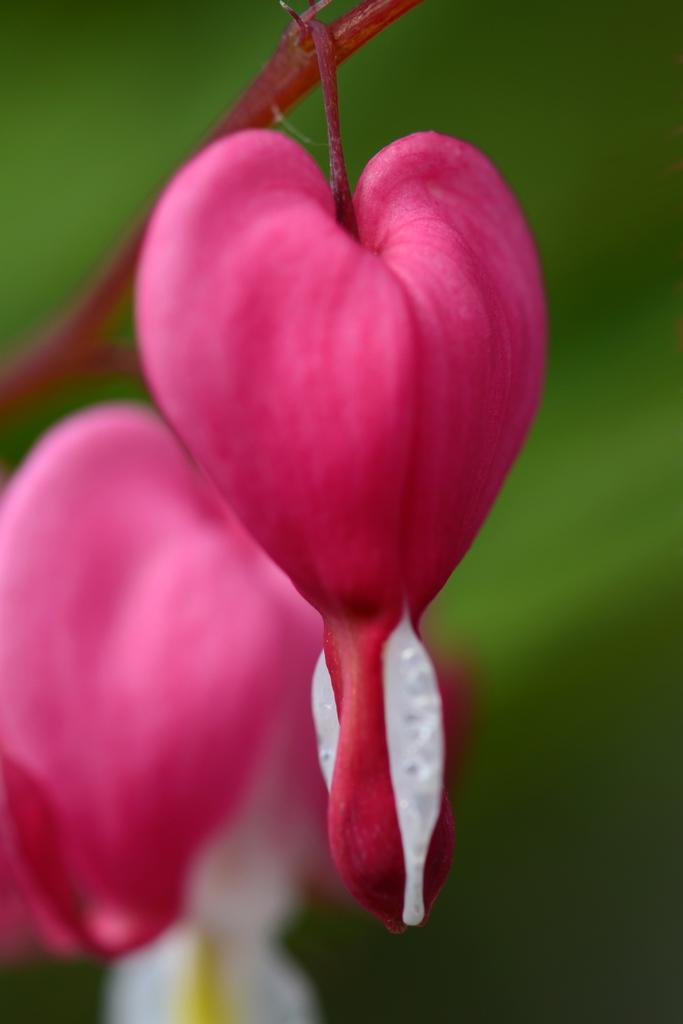What type of living organisms can be seen in the image? Flowers can be seen in the image. What type of print can be seen on the maid's uniform in the image? There is no maid or uniform present in the image; it only features flowers. 